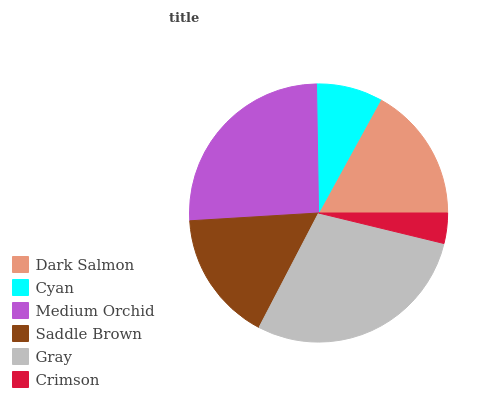Is Crimson the minimum?
Answer yes or no. Yes. Is Gray the maximum?
Answer yes or no. Yes. Is Cyan the minimum?
Answer yes or no. No. Is Cyan the maximum?
Answer yes or no. No. Is Dark Salmon greater than Cyan?
Answer yes or no. Yes. Is Cyan less than Dark Salmon?
Answer yes or no. Yes. Is Cyan greater than Dark Salmon?
Answer yes or no. No. Is Dark Salmon less than Cyan?
Answer yes or no. No. Is Dark Salmon the high median?
Answer yes or no. Yes. Is Saddle Brown the low median?
Answer yes or no. Yes. Is Saddle Brown the high median?
Answer yes or no. No. Is Gray the low median?
Answer yes or no. No. 